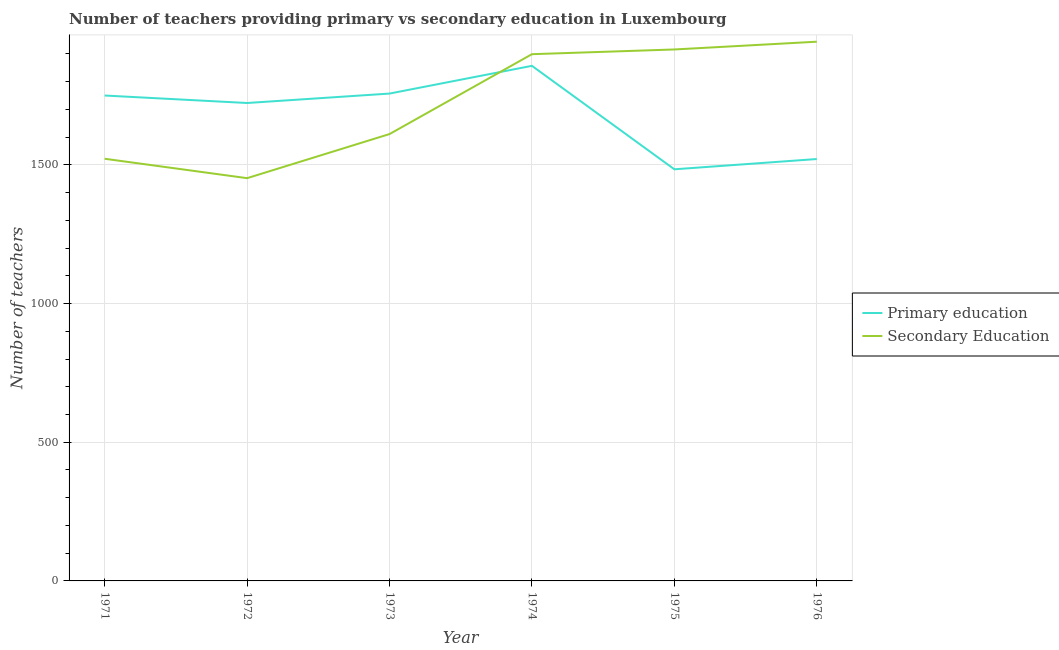Does the line corresponding to number of secondary teachers intersect with the line corresponding to number of primary teachers?
Your answer should be compact. Yes. Is the number of lines equal to the number of legend labels?
Make the answer very short. Yes. What is the number of primary teachers in 1973?
Your answer should be compact. 1757. Across all years, what is the maximum number of secondary teachers?
Provide a short and direct response. 1944. Across all years, what is the minimum number of secondary teachers?
Your answer should be compact. 1452. In which year was the number of primary teachers maximum?
Your answer should be compact. 1974. In which year was the number of secondary teachers minimum?
Provide a succinct answer. 1972. What is the total number of primary teachers in the graph?
Give a very brief answer. 1.01e+04. What is the difference between the number of secondary teachers in 1971 and that in 1972?
Your response must be concise. 70. What is the difference between the number of primary teachers in 1971 and the number of secondary teachers in 1975?
Ensure brevity in your answer.  -166. What is the average number of secondary teachers per year?
Your answer should be very brief. 1724. In the year 1975, what is the difference between the number of secondary teachers and number of primary teachers?
Offer a terse response. 432. In how many years, is the number of primary teachers greater than 700?
Make the answer very short. 6. What is the ratio of the number of secondary teachers in 1973 to that in 1976?
Offer a very short reply. 0.83. Is the number of secondary teachers in 1972 less than that in 1973?
Your response must be concise. Yes. Is the difference between the number of primary teachers in 1972 and 1976 greater than the difference between the number of secondary teachers in 1972 and 1976?
Make the answer very short. Yes. What is the difference between the highest and the lowest number of secondary teachers?
Offer a terse response. 492. In how many years, is the number of secondary teachers greater than the average number of secondary teachers taken over all years?
Ensure brevity in your answer.  3. Is the sum of the number of secondary teachers in 1971 and 1972 greater than the maximum number of primary teachers across all years?
Keep it short and to the point. Yes. Does the number of secondary teachers monotonically increase over the years?
Ensure brevity in your answer.  No. Is the number of secondary teachers strictly greater than the number of primary teachers over the years?
Give a very brief answer. No. Is the number of secondary teachers strictly less than the number of primary teachers over the years?
Provide a short and direct response. No. How many lines are there?
Offer a very short reply. 2. How many years are there in the graph?
Your answer should be compact. 6. Are the values on the major ticks of Y-axis written in scientific E-notation?
Your answer should be very brief. No. Does the graph contain any zero values?
Ensure brevity in your answer.  No. Does the graph contain grids?
Ensure brevity in your answer.  Yes. How many legend labels are there?
Provide a succinct answer. 2. What is the title of the graph?
Keep it short and to the point. Number of teachers providing primary vs secondary education in Luxembourg. Does "Working only" appear as one of the legend labels in the graph?
Make the answer very short. No. What is the label or title of the X-axis?
Keep it short and to the point. Year. What is the label or title of the Y-axis?
Make the answer very short. Number of teachers. What is the Number of teachers of Primary education in 1971?
Your answer should be compact. 1750. What is the Number of teachers in Secondary Education in 1971?
Give a very brief answer. 1522. What is the Number of teachers of Primary education in 1972?
Ensure brevity in your answer.  1723. What is the Number of teachers of Secondary Education in 1972?
Provide a succinct answer. 1452. What is the Number of teachers in Primary education in 1973?
Your response must be concise. 1757. What is the Number of teachers of Secondary Education in 1973?
Offer a terse response. 1611. What is the Number of teachers of Primary education in 1974?
Offer a terse response. 1857. What is the Number of teachers in Secondary Education in 1974?
Your answer should be compact. 1899. What is the Number of teachers of Primary education in 1975?
Offer a very short reply. 1484. What is the Number of teachers in Secondary Education in 1975?
Provide a short and direct response. 1916. What is the Number of teachers in Primary education in 1976?
Your answer should be very brief. 1521. What is the Number of teachers of Secondary Education in 1976?
Ensure brevity in your answer.  1944. Across all years, what is the maximum Number of teachers of Primary education?
Your answer should be compact. 1857. Across all years, what is the maximum Number of teachers in Secondary Education?
Provide a succinct answer. 1944. Across all years, what is the minimum Number of teachers of Primary education?
Provide a short and direct response. 1484. Across all years, what is the minimum Number of teachers of Secondary Education?
Your answer should be very brief. 1452. What is the total Number of teachers in Primary education in the graph?
Give a very brief answer. 1.01e+04. What is the total Number of teachers of Secondary Education in the graph?
Give a very brief answer. 1.03e+04. What is the difference between the Number of teachers of Secondary Education in 1971 and that in 1973?
Your response must be concise. -89. What is the difference between the Number of teachers in Primary education in 1971 and that in 1974?
Provide a short and direct response. -107. What is the difference between the Number of teachers of Secondary Education in 1971 and that in 1974?
Your answer should be very brief. -377. What is the difference between the Number of teachers in Primary education in 1971 and that in 1975?
Offer a very short reply. 266. What is the difference between the Number of teachers of Secondary Education in 1971 and that in 1975?
Your answer should be compact. -394. What is the difference between the Number of teachers in Primary education in 1971 and that in 1976?
Offer a terse response. 229. What is the difference between the Number of teachers in Secondary Education in 1971 and that in 1976?
Your answer should be compact. -422. What is the difference between the Number of teachers in Primary education in 1972 and that in 1973?
Provide a succinct answer. -34. What is the difference between the Number of teachers of Secondary Education in 1972 and that in 1973?
Provide a short and direct response. -159. What is the difference between the Number of teachers of Primary education in 1972 and that in 1974?
Offer a terse response. -134. What is the difference between the Number of teachers of Secondary Education in 1972 and that in 1974?
Your answer should be compact. -447. What is the difference between the Number of teachers in Primary education in 1972 and that in 1975?
Provide a succinct answer. 239. What is the difference between the Number of teachers in Secondary Education in 1972 and that in 1975?
Your response must be concise. -464. What is the difference between the Number of teachers of Primary education in 1972 and that in 1976?
Offer a very short reply. 202. What is the difference between the Number of teachers in Secondary Education in 1972 and that in 1976?
Your response must be concise. -492. What is the difference between the Number of teachers in Primary education in 1973 and that in 1974?
Your answer should be compact. -100. What is the difference between the Number of teachers in Secondary Education in 1973 and that in 1974?
Keep it short and to the point. -288. What is the difference between the Number of teachers in Primary education in 1973 and that in 1975?
Offer a terse response. 273. What is the difference between the Number of teachers of Secondary Education in 1973 and that in 1975?
Keep it short and to the point. -305. What is the difference between the Number of teachers of Primary education in 1973 and that in 1976?
Offer a terse response. 236. What is the difference between the Number of teachers of Secondary Education in 1973 and that in 1976?
Provide a short and direct response. -333. What is the difference between the Number of teachers in Primary education in 1974 and that in 1975?
Give a very brief answer. 373. What is the difference between the Number of teachers of Primary education in 1974 and that in 1976?
Offer a terse response. 336. What is the difference between the Number of teachers in Secondary Education in 1974 and that in 1976?
Your answer should be very brief. -45. What is the difference between the Number of teachers of Primary education in 1975 and that in 1976?
Give a very brief answer. -37. What is the difference between the Number of teachers in Primary education in 1971 and the Number of teachers in Secondary Education in 1972?
Provide a short and direct response. 298. What is the difference between the Number of teachers in Primary education in 1971 and the Number of teachers in Secondary Education in 1973?
Ensure brevity in your answer.  139. What is the difference between the Number of teachers in Primary education in 1971 and the Number of teachers in Secondary Education in 1974?
Your answer should be very brief. -149. What is the difference between the Number of teachers in Primary education in 1971 and the Number of teachers in Secondary Education in 1975?
Your answer should be compact. -166. What is the difference between the Number of teachers in Primary education in 1971 and the Number of teachers in Secondary Education in 1976?
Offer a terse response. -194. What is the difference between the Number of teachers of Primary education in 1972 and the Number of teachers of Secondary Education in 1973?
Your response must be concise. 112. What is the difference between the Number of teachers in Primary education in 1972 and the Number of teachers in Secondary Education in 1974?
Provide a succinct answer. -176. What is the difference between the Number of teachers of Primary education in 1972 and the Number of teachers of Secondary Education in 1975?
Give a very brief answer. -193. What is the difference between the Number of teachers of Primary education in 1972 and the Number of teachers of Secondary Education in 1976?
Give a very brief answer. -221. What is the difference between the Number of teachers of Primary education in 1973 and the Number of teachers of Secondary Education in 1974?
Keep it short and to the point. -142. What is the difference between the Number of teachers of Primary education in 1973 and the Number of teachers of Secondary Education in 1975?
Your response must be concise. -159. What is the difference between the Number of teachers of Primary education in 1973 and the Number of teachers of Secondary Education in 1976?
Offer a terse response. -187. What is the difference between the Number of teachers of Primary education in 1974 and the Number of teachers of Secondary Education in 1975?
Provide a succinct answer. -59. What is the difference between the Number of teachers of Primary education in 1974 and the Number of teachers of Secondary Education in 1976?
Provide a short and direct response. -87. What is the difference between the Number of teachers of Primary education in 1975 and the Number of teachers of Secondary Education in 1976?
Make the answer very short. -460. What is the average Number of teachers in Primary education per year?
Offer a very short reply. 1682. What is the average Number of teachers of Secondary Education per year?
Provide a short and direct response. 1724. In the year 1971, what is the difference between the Number of teachers in Primary education and Number of teachers in Secondary Education?
Your answer should be compact. 228. In the year 1972, what is the difference between the Number of teachers of Primary education and Number of teachers of Secondary Education?
Your response must be concise. 271. In the year 1973, what is the difference between the Number of teachers of Primary education and Number of teachers of Secondary Education?
Your answer should be very brief. 146. In the year 1974, what is the difference between the Number of teachers of Primary education and Number of teachers of Secondary Education?
Provide a succinct answer. -42. In the year 1975, what is the difference between the Number of teachers of Primary education and Number of teachers of Secondary Education?
Provide a succinct answer. -432. In the year 1976, what is the difference between the Number of teachers in Primary education and Number of teachers in Secondary Education?
Provide a short and direct response. -423. What is the ratio of the Number of teachers of Primary education in 1971 to that in 1972?
Give a very brief answer. 1.02. What is the ratio of the Number of teachers of Secondary Education in 1971 to that in 1972?
Offer a terse response. 1.05. What is the ratio of the Number of teachers of Primary education in 1971 to that in 1973?
Keep it short and to the point. 1. What is the ratio of the Number of teachers in Secondary Education in 1971 to that in 1973?
Provide a succinct answer. 0.94. What is the ratio of the Number of teachers of Primary education in 1971 to that in 1974?
Keep it short and to the point. 0.94. What is the ratio of the Number of teachers in Secondary Education in 1971 to that in 1974?
Your response must be concise. 0.8. What is the ratio of the Number of teachers of Primary education in 1971 to that in 1975?
Make the answer very short. 1.18. What is the ratio of the Number of teachers of Secondary Education in 1971 to that in 1975?
Keep it short and to the point. 0.79. What is the ratio of the Number of teachers in Primary education in 1971 to that in 1976?
Provide a succinct answer. 1.15. What is the ratio of the Number of teachers in Secondary Education in 1971 to that in 1976?
Your answer should be very brief. 0.78. What is the ratio of the Number of teachers in Primary education in 1972 to that in 1973?
Keep it short and to the point. 0.98. What is the ratio of the Number of teachers of Secondary Education in 1972 to that in 1973?
Provide a succinct answer. 0.9. What is the ratio of the Number of teachers in Primary education in 1972 to that in 1974?
Your answer should be very brief. 0.93. What is the ratio of the Number of teachers of Secondary Education in 1972 to that in 1974?
Provide a succinct answer. 0.76. What is the ratio of the Number of teachers in Primary education in 1972 to that in 1975?
Give a very brief answer. 1.16. What is the ratio of the Number of teachers in Secondary Education in 1972 to that in 1975?
Offer a very short reply. 0.76. What is the ratio of the Number of teachers of Primary education in 1972 to that in 1976?
Give a very brief answer. 1.13. What is the ratio of the Number of teachers in Secondary Education in 1972 to that in 1976?
Make the answer very short. 0.75. What is the ratio of the Number of teachers in Primary education in 1973 to that in 1974?
Offer a very short reply. 0.95. What is the ratio of the Number of teachers in Secondary Education in 1973 to that in 1974?
Provide a succinct answer. 0.85. What is the ratio of the Number of teachers of Primary education in 1973 to that in 1975?
Offer a terse response. 1.18. What is the ratio of the Number of teachers of Secondary Education in 1973 to that in 1975?
Your response must be concise. 0.84. What is the ratio of the Number of teachers of Primary education in 1973 to that in 1976?
Make the answer very short. 1.16. What is the ratio of the Number of teachers of Secondary Education in 1973 to that in 1976?
Ensure brevity in your answer.  0.83. What is the ratio of the Number of teachers in Primary education in 1974 to that in 1975?
Offer a very short reply. 1.25. What is the ratio of the Number of teachers of Primary education in 1974 to that in 1976?
Your answer should be very brief. 1.22. What is the ratio of the Number of teachers in Secondary Education in 1974 to that in 1976?
Make the answer very short. 0.98. What is the ratio of the Number of teachers in Primary education in 1975 to that in 1976?
Provide a succinct answer. 0.98. What is the ratio of the Number of teachers in Secondary Education in 1975 to that in 1976?
Your response must be concise. 0.99. What is the difference between the highest and the lowest Number of teachers in Primary education?
Offer a very short reply. 373. What is the difference between the highest and the lowest Number of teachers of Secondary Education?
Offer a very short reply. 492. 